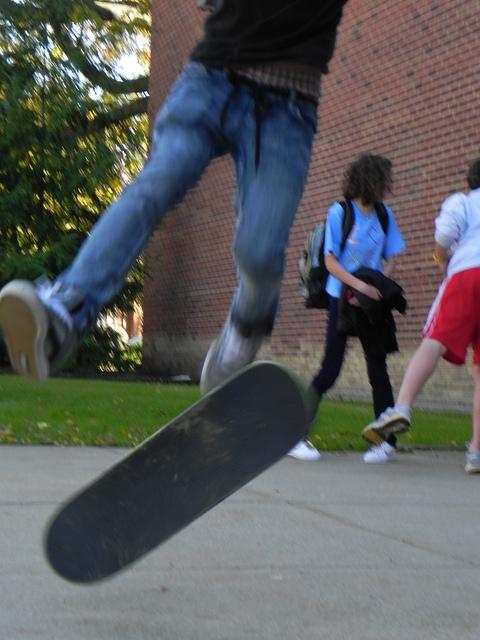What is the person in the blue have on their back?
Short answer required. Backpack. Are the two people behind the skater watching him?
Short answer required. No. How many untied shoelaces are visible?
Concise answer only. 0. 